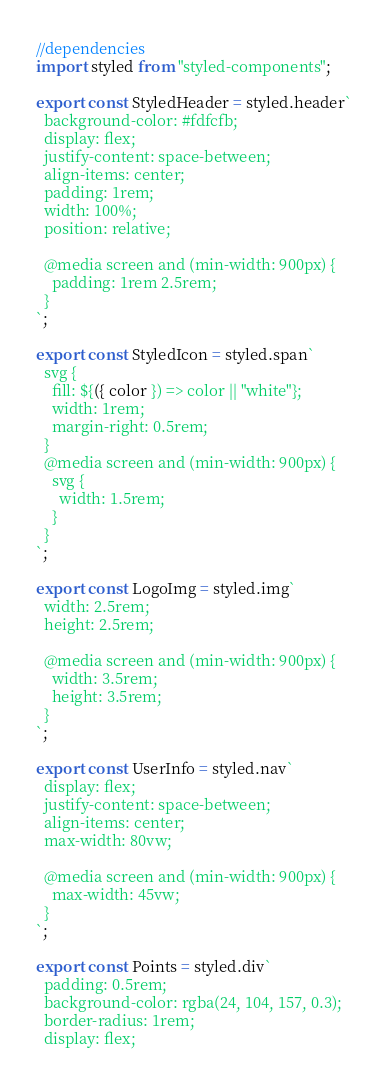Convert code to text. <code><loc_0><loc_0><loc_500><loc_500><_JavaScript_>//dependencies
import styled from "styled-components";

export const StyledHeader = styled.header`
  background-color: #fdfcfb;
  display: flex;
  justify-content: space-between;
  align-items: center;
  padding: 1rem;
  width: 100%;
  position: relative;

  @media screen and (min-width: 900px) {
    padding: 1rem 2.5rem;
  }
`;

export const StyledIcon = styled.span`
  svg {
    fill: ${({ color }) => color || "white"};
    width: 1rem;
    margin-right: 0.5rem;
  }
  @media screen and (min-width: 900px) {
    svg {
      width: 1.5rem;
    }
  }
`;

export const LogoImg = styled.img`
  width: 2.5rem;
  height: 2.5rem;

  @media screen and (min-width: 900px) {
    width: 3.5rem;
    height: 3.5rem;
  }
`;

export const UserInfo = styled.nav`
  display: flex;
  justify-content: space-between;
  align-items: center;
  max-width: 80vw;

  @media screen and (min-width: 900px) {
    max-width: 45vw;
  }
`;

export const Points = styled.div`
  padding: 0.5rem;
  background-color: rgba(24, 104, 157, 0.3);
  border-radius: 1rem;
  display: flex;</code> 